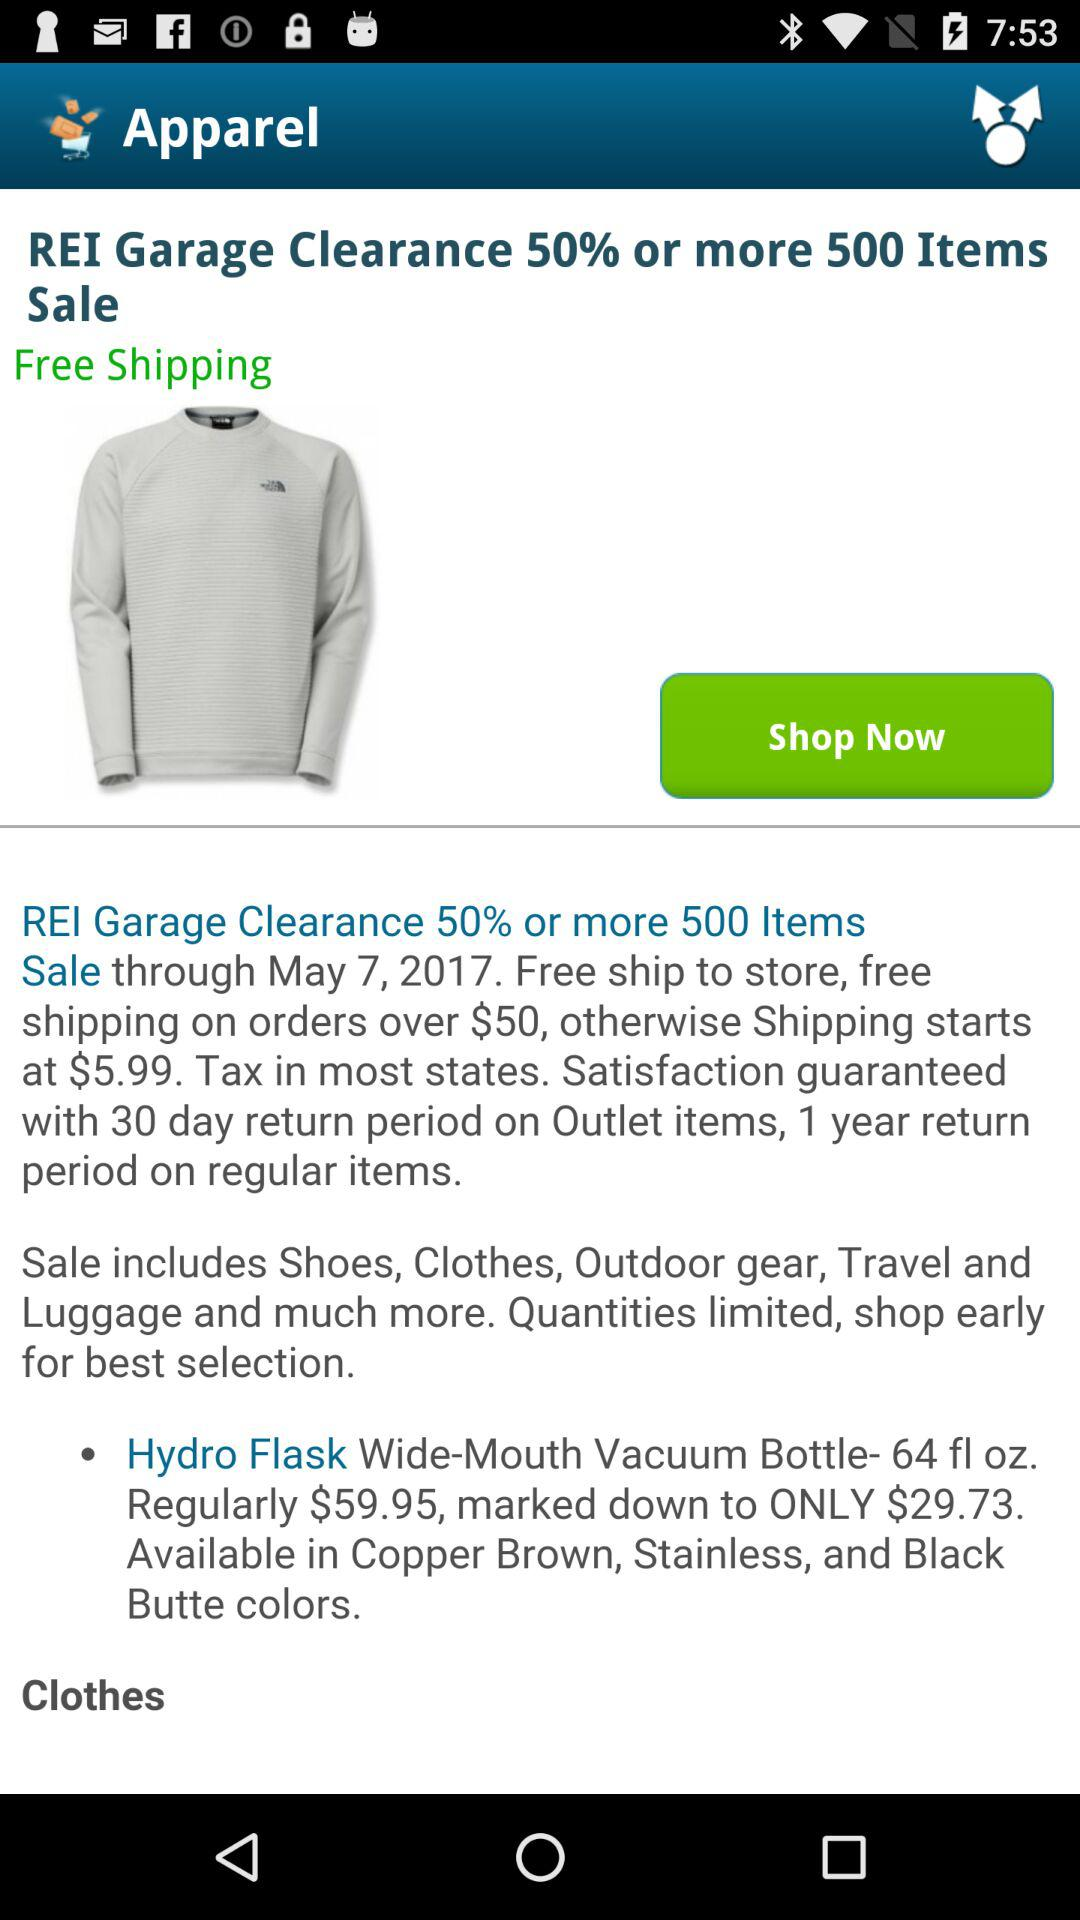What is the shipping amount on orders over $50? Shipping is free on orders over $50. 